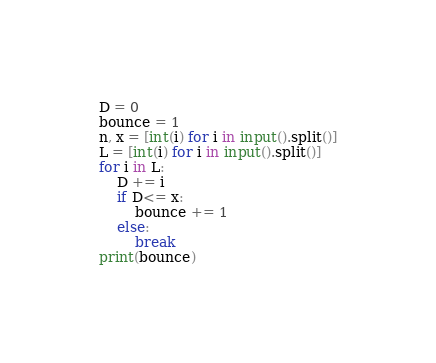<code> <loc_0><loc_0><loc_500><loc_500><_Python_>D = 0
bounce = 1
n, x = [int(i) for i in input().split()]
L = [int(i) for i in input().split()]
for i in L:
    D += i
    if D<= x:
        bounce += 1
    else:
        break
print(bounce)</code> 